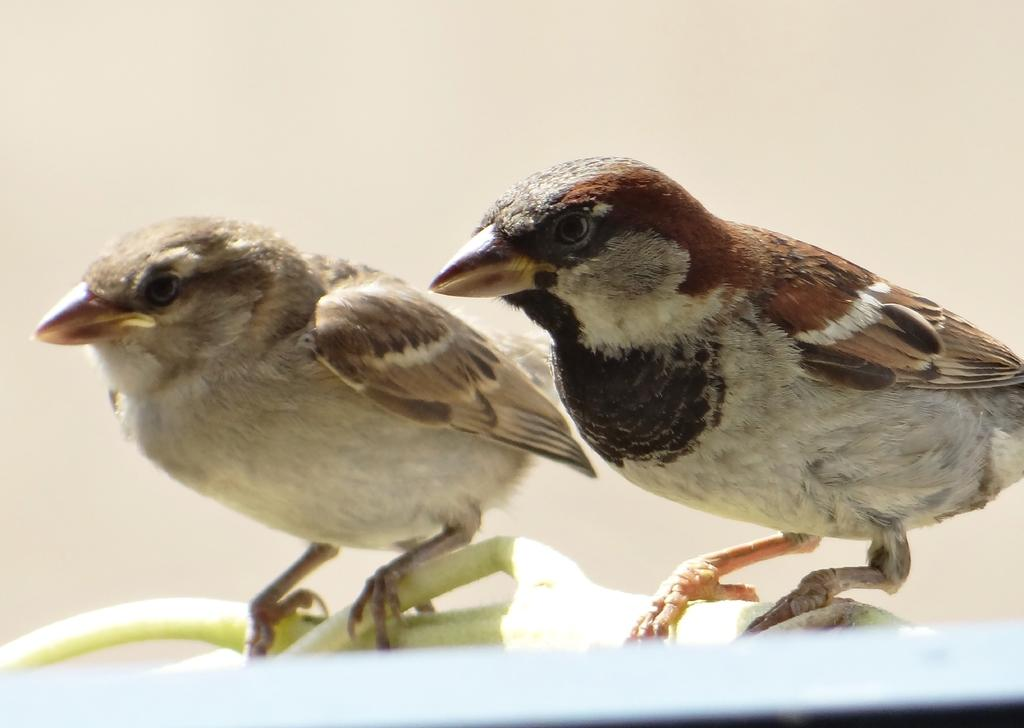How many birds can be seen in the image? There are two birds in the image. Where are the birds located? The birds are on a stem. Which direction are the birds facing? The birds are facing towards the left side. What can be seen in the background of the image? There is a wall in the background of the image. Is there a man standing behind the wall in the image? There is no man present in the image; it only features two birds on a stem and a wall in the background. 